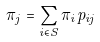Convert formula to latex. <formula><loc_0><loc_0><loc_500><loc_500>\pi _ { j } = \sum _ { i \in S } \pi _ { i } p _ { i j }</formula> 